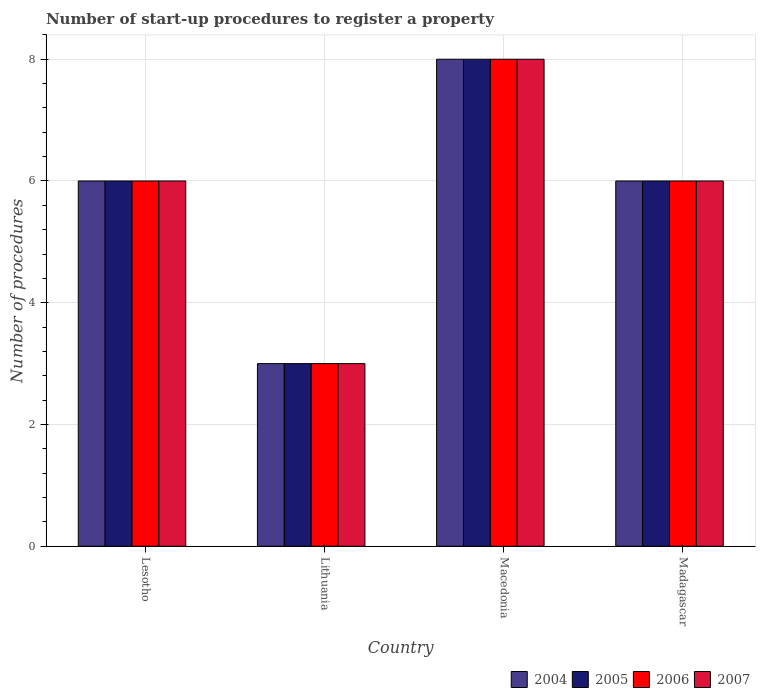How many groups of bars are there?
Offer a very short reply. 4. Are the number of bars on each tick of the X-axis equal?
Your answer should be compact. Yes. What is the label of the 2nd group of bars from the left?
Your answer should be compact. Lithuania. Across all countries, what is the minimum number of procedures required to register a property in 2006?
Your answer should be compact. 3. In which country was the number of procedures required to register a property in 2004 maximum?
Provide a short and direct response. Macedonia. In which country was the number of procedures required to register a property in 2004 minimum?
Your response must be concise. Lithuania. What is the average number of procedures required to register a property in 2007 per country?
Make the answer very short. 5.75. What is the difference between the number of procedures required to register a property of/in 2004 and number of procedures required to register a property of/in 2007 in Madagascar?
Your answer should be compact. 0. What is the ratio of the number of procedures required to register a property in 2004 in Macedonia to that in Madagascar?
Keep it short and to the point. 1.33. What is the difference between the highest and the lowest number of procedures required to register a property in 2005?
Offer a very short reply. 5. In how many countries, is the number of procedures required to register a property in 2004 greater than the average number of procedures required to register a property in 2004 taken over all countries?
Your response must be concise. 3. Is the sum of the number of procedures required to register a property in 2004 in Lesotho and Lithuania greater than the maximum number of procedures required to register a property in 2007 across all countries?
Offer a very short reply. Yes. What does the 3rd bar from the right in Lesotho represents?
Give a very brief answer. 2005. Is it the case that in every country, the sum of the number of procedures required to register a property in 2005 and number of procedures required to register a property in 2004 is greater than the number of procedures required to register a property in 2007?
Offer a very short reply. Yes. What is the difference between two consecutive major ticks on the Y-axis?
Your answer should be compact. 2. Are the values on the major ticks of Y-axis written in scientific E-notation?
Give a very brief answer. No. Does the graph contain any zero values?
Make the answer very short. No. What is the title of the graph?
Your response must be concise. Number of start-up procedures to register a property. Does "2007" appear as one of the legend labels in the graph?
Provide a short and direct response. Yes. What is the label or title of the Y-axis?
Offer a terse response. Number of procedures. What is the Number of procedures in 2004 in Lesotho?
Give a very brief answer. 6. What is the Number of procedures in 2006 in Lesotho?
Offer a very short reply. 6. What is the Number of procedures of 2007 in Lithuania?
Give a very brief answer. 3. What is the Number of procedures in 2005 in Macedonia?
Keep it short and to the point. 8. What is the Number of procedures in 2006 in Madagascar?
Your answer should be very brief. 6. Across all countries, what is the maximum Number of procedures of 2006?
Your response must be concise. 8. Across all countries, what is the maximum Number of procedures in 2007?
Provide a short and direct response. 8. Across all countries, what is the minimum Number of procedures in 2005?
Provide a succinct answer. 3. Across all countries, what is the minimum Number of procedures of 2006?
Your answer should be very brief. 3. What is the total Number of procedures of 2004 in the graph?
Ensure brevity in your answer.  23. What is the difference between the Number of procedures in 2005 in Lesotho and that in Lithuania?
Provide a short and direct response. 3. What is the difference between the Number of procedures of 2006 in Lesotho and that in Lithuania?
Your response must be concise. 3. What is the difference between the Number of procedures of 2004 in Lesotho and that in Macedonia?
Provide a short and direct response. -2. What is the difference between the Number of procedures in 2007 in Lesotho and that in Macedonia?
Provide a succinct answer. -2. What is the difference between the Number of procedures of 2004 in Lithuania and that in Macedonia?
Provide a succinct answer. -5. What is the difference between the Number of procedures in 2005 in Lithuania and that in Macedonia?
Make the answer very short. -5. What is the difference between the Number of procedures of 2006 in Lithuania and that in Macedonia?
Offer a terse response. -5. What is the difference between the Number of procedures in 2006 in Lithuania and that in Madagascar?
Your response must be concise. -3. What is the difference between the Number of procedures in 2005 in Macedonia and that in Madagascar?
Make the answer very short. 2. What is the difference between the Number of procedures in 2004 in Lesotho and the Number of procedures in 2006 in Lithuania?
Give a very brief answer. 3. What is the difference between the Number of procedures in 2004 in Lesotho and the Number of procedures in 2005 in Macedonia?
Keep it short and to the point. -2. What is the difference between the Number of procedures of 2004 in Lesotho and the Number of procedures of 2007 in Macedonia?
Your answer should be very brief. -2. What is the difference between the Number of procedures in 2004 in Lesotho and the Number of procedures in 2006 in Madagascar?
Provide a succinct answer. 0. What is the difference between the Number of procedures in 2004 in Lesotho and the Number of procedures in 2007 in Madagascar?
Your answer should be very brief. 0. What is the difference between the Number of procedures of 2005 in Lesotho and the Number of procedures of 2006 in Madagascar?
Make the answer very short. 0. What is the difference between the Number of procedures in 2006 in Lesotho and the Number of procedures in 2007 in Madagascar?
Offer a very short reply. 0. What is the difference between the Number of procedures of 2005 in Lithuania and the Number of procedures of 2006 in Macedonia?
Your answer should be very brief. -5. What is the difference between the Number of procedures in 2005 in Lithuania and the Number of procedures in 2007 in Macedonia?
Give a very brief answer. -5. What is the difference between the Number of procedures in 2006 in Lithuania and the Number of procedures in 2007 in Macedonia?
Give a very brief answer. -5. What is the difference between the Number of procedures in 2004 in Lithuania and the Number of procedures in 2006 in Madagascar?
Offer a very short reply. -3. What is the difference between the Number of procedures in 2004 in Lithuania and the Number of procedures in 2007 in Madagascar?
Provide a succinct answer. -3. What is the difference between the Number of procedures in 2005 in Lithuania and the Number of procedures in 2006 in Madagascar?
Offer a terse response. -3. What is the difference between the Number of procedures in 2006 in Lithuania and the Number of procedures in 2007 in Madagascar?
Your answer should be very brief. -3. What is the difference between the Number of procedures of 2004 in Macedonia and the Number of procedures of 2007 in Madagascar?
Keep it short and to the point. 2. What is the average Number of procedures of 2004 per country?
Your response must be concise. 5.75. What is the average Number of procedures of 2005 per country?
Provide a short and direct response. 5.75. What is the average Number of procedures in 2006 per country?
Keep it short and to the point. 5.75. What is the average Number of procedures of 2007 per country?
Provide a short and direct response. 5.75. What is the difference between the Number of procedures of 2004 and Number of procedures of 2005 in Lesotho?
Offer a very short reply. 0. What is the difference between the Number of procedures in 2005 and Number of procedures in 2006 in Lesotho?
Offer a terse response. 0. What is the difference between the Number of procedures of 2005 and Number of procedures of 2006 in Lithuania?
Keep it short and to the point. 0. What is the difference between the Number of procedures in 2004 and Number of procedures in 2005 in Macedonia?
Keep it short and to the point. 0. What is the difference between the Number of procedures of 2006 and Number of procedures of 2007 in Macedonia?
Ensure brevity in your answer.  0. What is the difference between the Number of procedures in 2004 and Number of procedures in 2005 in Madagascar?
Your answer should be very brief. 0. What is the difference between the Number of procedures of 2005 and Number of procedures of 2006 in Madagascar?
Your answer should be compact. 0. What is the difference between the Number of procedures of 2005 and Number of procedures of 2007 in Madagascar?
Offer a very short reply. 0. What is the difference between the Number of procedures of 2006 and Number of procedures of 2007 in Madagascar?
Give a very brief answer. 0. What is the ratio of the Number of procedures of 2004 in Lesotho to that in Lithuania?
Ensure brevity in your answer.  2. What is the ratio of the Number of procedures in 2006 in Lesotho to that in Lithuania?
Give a very brief answer. 2. What is the ratio of the Number of procedures of 2004 in Lesotho to that in Macedonia?
Make the answer very short. 0.75. What is the ratio of the Number of procedures in 2006 in Lesotho to that in Macedonia?
Make the answer very short. 0.75. What is the ratio of the Number of procedures of 2007 in Lesotho to that in Macedonia?
Your answer should be very brief. 0.75. What is the ratio of the Number of procedures in 2004 in Lesotho to that in Madagascar?
Ensure brevity in your answer.  1. What is the ratio of the Number of procedures in 2005 in Lesotho to that in Madagascar?
Provide a succinct answer. 1. What is the ratio of the Number of procedures in 2004 in Lithuania to that in Macedonia?
Ensure brevity in your answer.  0.38. What is the ratio of the Number of procedures of 2005 in Lithuania to that in Macedonia?
Your answer should be very brief. 0.38. What is the ratio of the Number of procedures in 2006 in Lithuania to that in Macedonia?
Offer a very short reply. 0.38. What is the ratio of the Number of procedures of 2004 in Lithuania to that in Madagascar?
Offer a terse response. 0.5. What is the ratio of the Number of procedures in 2007 in Lithuania to that in Madagascar?
Make the answer very short. 0.5. What is the ratio of the Number of procedures in 2007 in Macedonia to that in Madagascar?
Your response must be concise. 1.33. What is the difference between the highest and the second highest Number of procedures of 2004?
Your response must be concise. 2. What is the difference between the highest and the second highest Number of procedures in 2005?
Offer a terse response. 2. What is the difference between the highest and the second highest Number of procedures of 2007?
Your answer should be compact. 2. What is the difference between the highest and the lowest Number of procedures of 2004?
Your response must be concise. 5. What is the difference between the highest and the lowest Number of procedures in 2006?
Offer a terse response. 5. What is the difference between the highest and the lowest Number of procedures of 2007?
Ensure brevity in your answer.  5. 